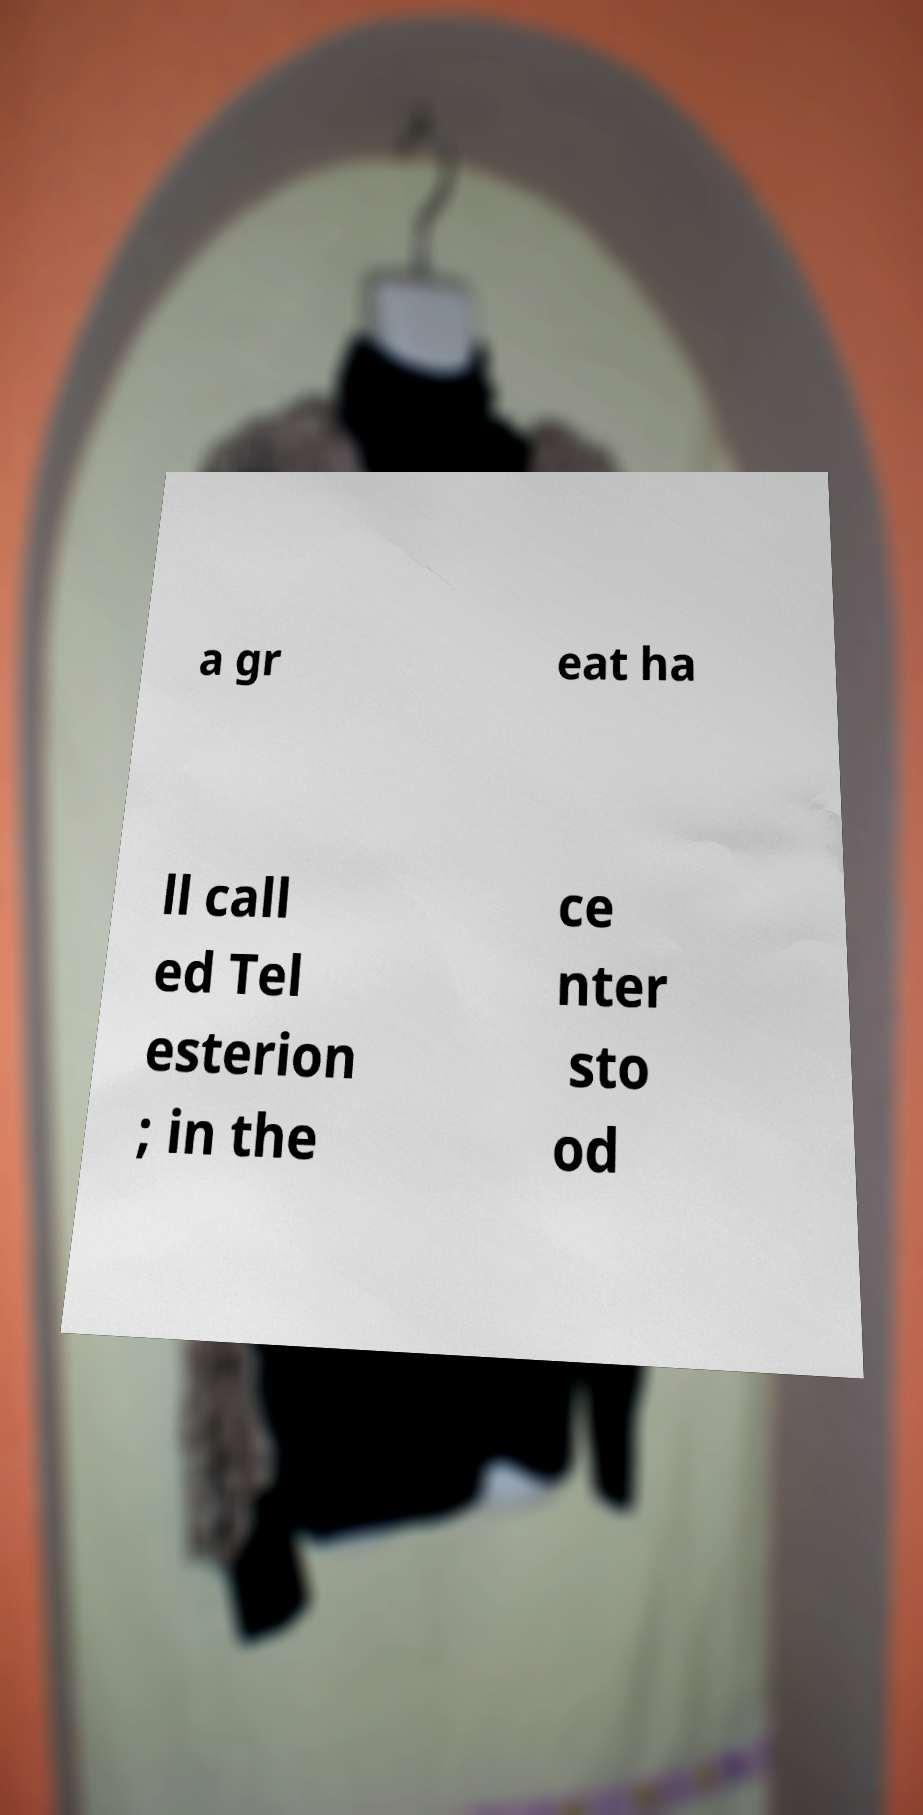I need the written content from this picture converted into text. Can you do that? a gr eat ha ll call ed Tel esterion ; in the ce nter sto od 